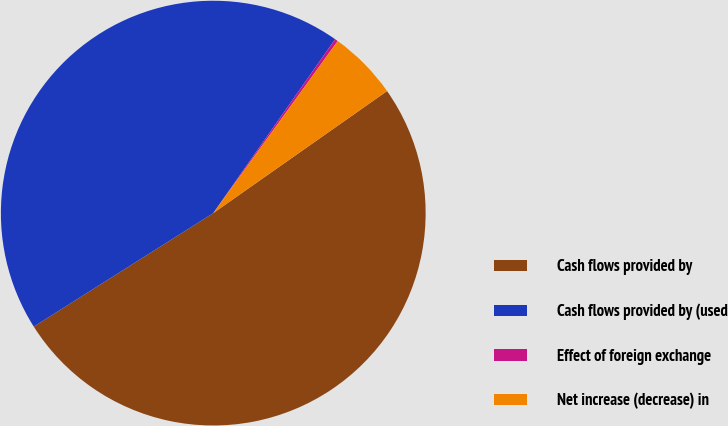<chart> <loc_0><loc_0><loc_500><loc_500><pie_chart><fcel>Cash flows provided by<fcel>Cash flows provided by (used<fcel>Effect of foreign exchange<fcel>Net increase (decrease) in<nl><fcel>50.77%<fcel>43.7%<fcel>0.24%<fcel>5.29%<nl></chart> 